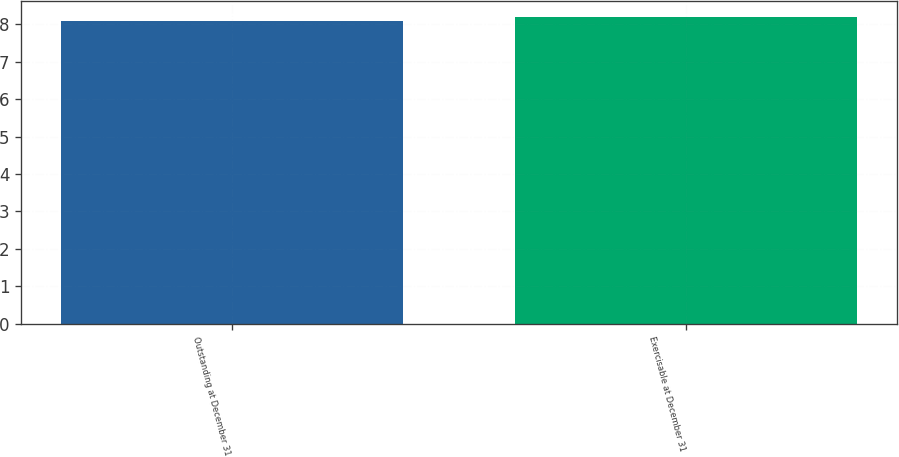Convert chart. <chart><loc_0><loc_0><loc_500><loc_500><bar_chart><fcel>Outstanding at December 31<fcel>Exercisable at December 31<nl><fcel>8.1<fcel>8.2<nl></chart> 